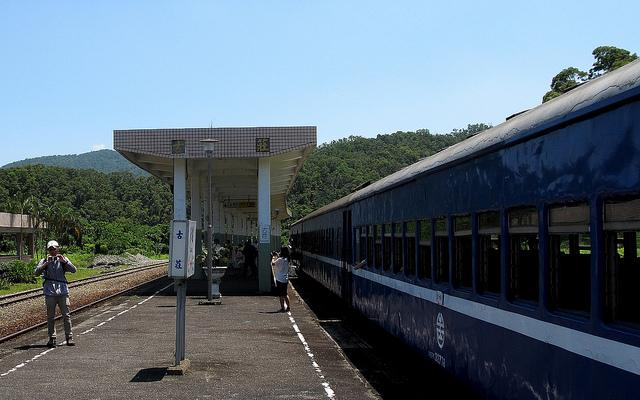Who is sheltered here? train passengers 